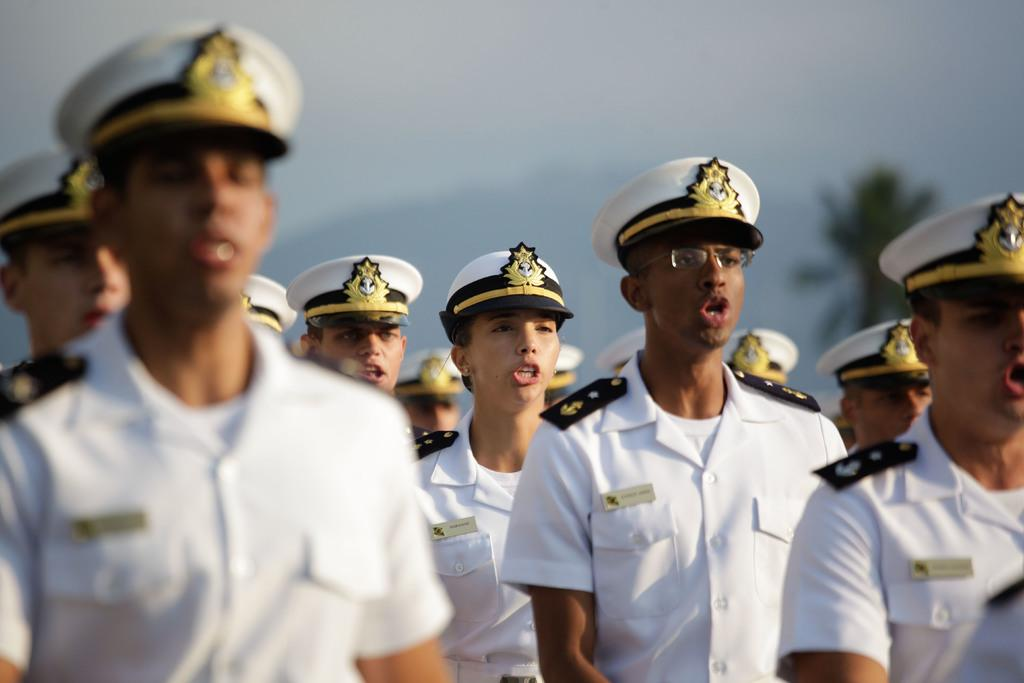What can be seen in the image? There are people in the image. What are the people wearing? The people are wearing white police uniforms and white caps. Can you describe the background of the image? There is a tree at the right back of the image. What type of mist can be seen surrounding the people in the image? There is no mist present in the image; it only features people wearing white police uniforms and white caps, with a tree in the background. 